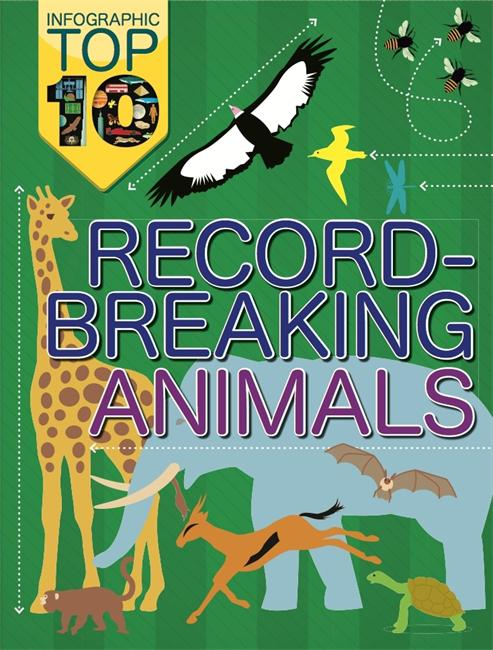An info graph is a visual image like a poster that is used to represent information or data about any object. For this task, the input will be a info graph. Identify the main object of the info graph. The infographic prominently features a collection of record-breaking animals, each illustrated in a vibrant, engaging style that captures the viewer's attention. It is designed to educate and inform about various animals that hold world records in categories such as speed, size, longevity, and other remarkable traits. The layout is carefully structured to guide the viewer's eye through the different records, making it informative yet easy to understand. Additional details, like record statistics or specific anecdotes about the animals, could enrich the learning experience, offering a deeper insight into nature's extremes. 